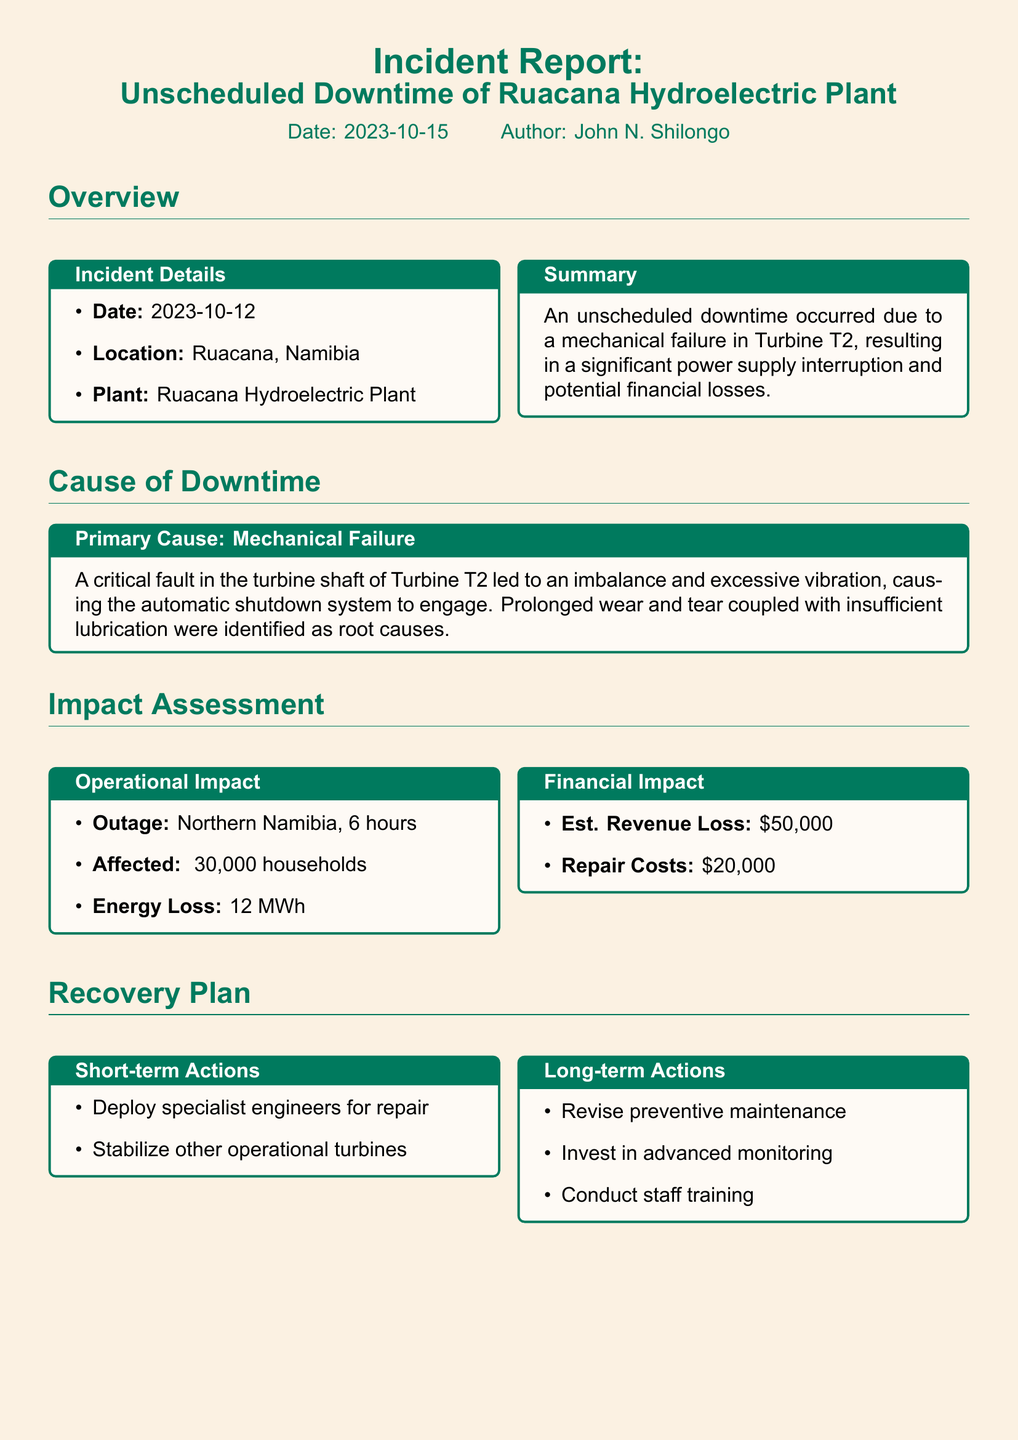what is the date of the incident? The incident date is mentioned in the document under Incident Details.
Answer: 2023-10-12 what is the location of the hydroelectric plant? The location of the plant is specified in the Overview section.
Answer: Ruacana, Namibia what was the estimated revenue loss? The financial impact section specifies the estimated revenue loss due to the incident.
Answer: $50,000 how many households were affected by the outage? The document provides the number of affected households under Operational Impact.
Answer: ~30,000 households what was the duration of the outage? The duration of the outage is given in the Operational Impact section.
Answer: 6 hours what are the short-term actions in the recovery plan? Short-term actions are listed in the Recovery Plan section.
Answer: Deploy specialist engineers for repair, Stabilize other operational turbines what caused the mechanical failure? The cause of downtime section explains the cause of the mechanical failure in detail.
Answer: A critical fault in the turbine shaft what is the energy loss reported due to the incident? The energy loss figure is provided in the Operational Impact section of the document.
Answer: 12 MWh what are the long-term actions proposed in the recovery plan? The document lists long-term actions in the recovery plan section.
Answer: Revise preventive maintenance, Invest in advanced monitoring, Conduct staff training 